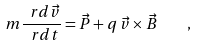<formula> <loc_0><loc_0><loc_500><loc_500>m \frac { \ r d \vec { v } } { \ r d t } = \vec { P } + q \, \vec { v } \times \vec { B } \quad ,</formula> 